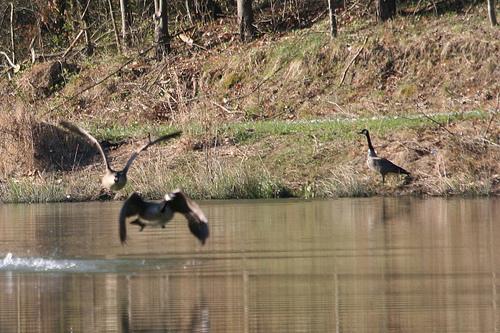How many geese are there?
Short answer required. 3. What is the animal doing?
Short answer required. Flying. How many cranes?
Give a very brief answer. 3. Are these geese taking off or landing?
Answer briefly. Taking off. What are the geese flying over?
Give a very brief answer. Water. Are the birds in the water?
Quick response, please. No. What animal does that look like?
Write a very short answer. Goose. 